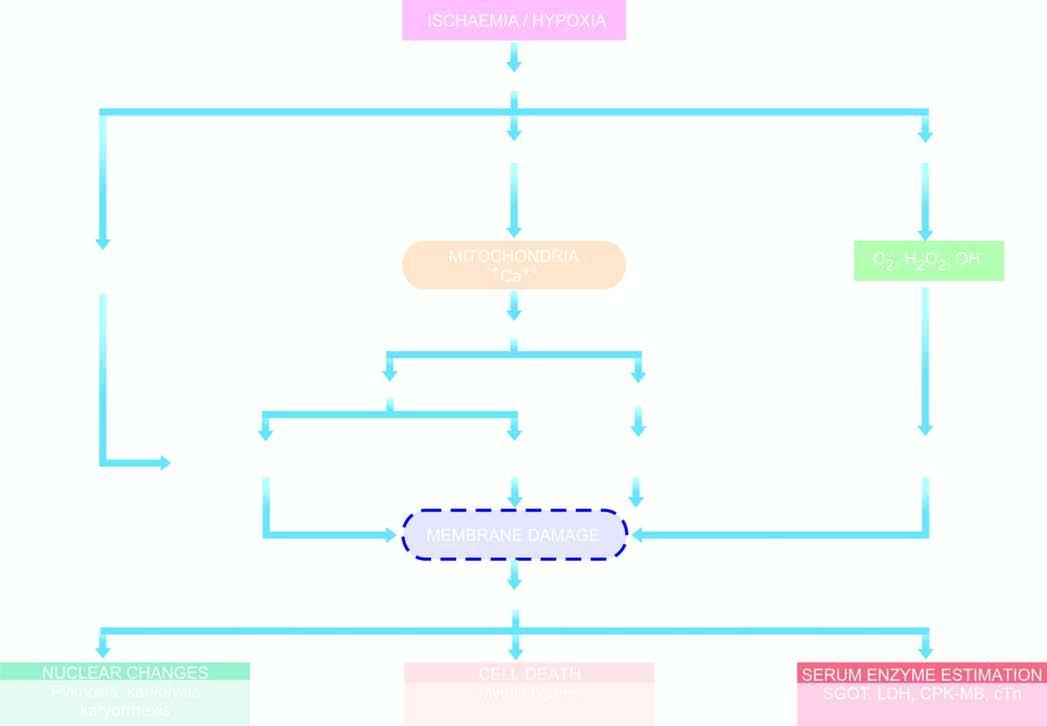s m phase caused by hypoxia/ischaemia?
Answer the question using a single word or phrase. No 